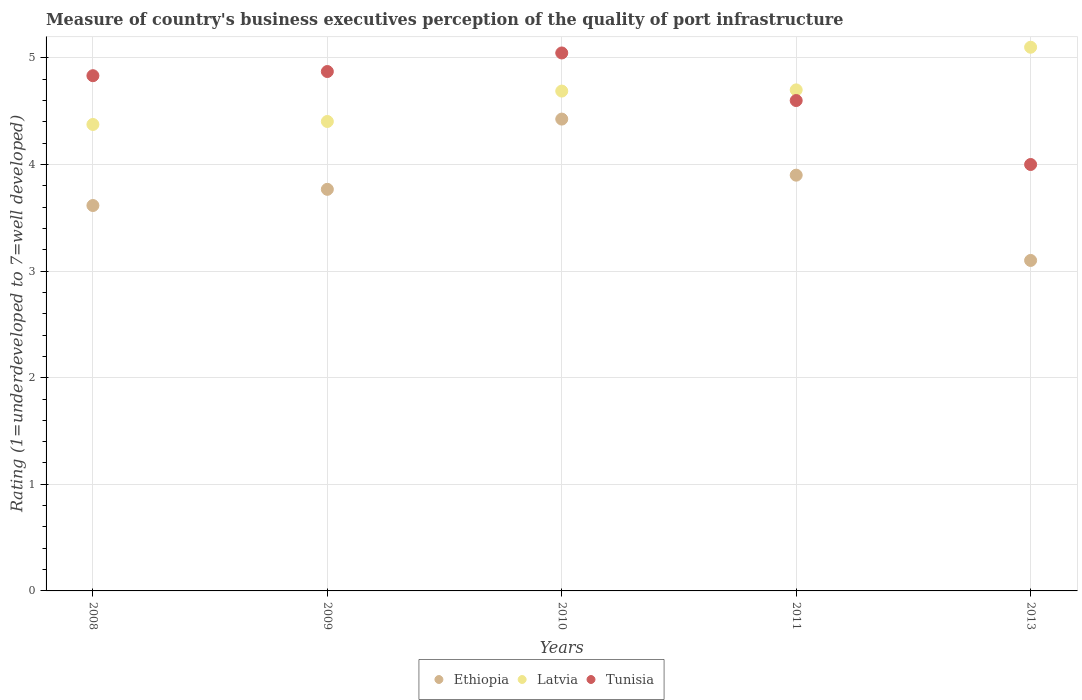How many different coloured dotlines are there?
Offer a terse response. 3. Is the number of dotlines equal to the number of legend labels?
Offer a terse response. Yes. What is the ratings of the quality of port infrastructure in Latvia in 2008?
Provide a short and direct response. 4.38. Across all years, what is the maximum ratings of the quality of port infrastructure in Ethiopia?
Ensure brevity in your answer.  4.43. Across all years, what is the minimum ratings of the quality of port infrastructure in Ethiopia?
Offer a terse response. 3.1. What is the total ratings of the quality of port infrastructure in Latvia in the graph?
Your answer should be compact. 23.27. What is the difference between the ratings of the quality of port infrastructure in Ethiopia in 2010 and that in 2011?
Provide a short and direct response. 0.53. What is the difference between the ratings of the quality of port infrastructure in Latvia in 2011 and the ratings of the quality of port infrastructure in Tunisia in 2013?
Offer a very short reply. 0.7. What is the average ratings of the quality of port infrastructure in Tunisia per year?
Offer a very short reply. 4.67. In the year 2013, what is the difference between the ratings of the quality of port infrastructure in Tunisia and ratings of the quality of port infrastructure in Ethiopia?
Give a very brief answer. 0.9. What is the ratio of the ratings of the quality of port infrastructure in Ethiopia in 2009 to that in 2013?
Provide a succinct answer. 1.22. Is the ratings of the quality of port infrastructure in Ethiopia in 2009 less than that in 2011?
Ensure brevity in your answer.  Yes. What is the difference between the highest and the second highest ratings of the quality of port infrastructure in Tunisia?
Give a very brief answer. 0.17. What is the difference between the highest and the lowest ratings of the quality of port infrastructure in Tunisia?
Keep it short and to the point. 1.05. In how many years, is the ratings of the quality of port infrastructure in Tunisia greater than the average ratings of the quality of port infrastructure in Tunisia taken over all years?
Give a very brief answer. 3. Is it the case that in every year, the sum of the ratings of the quality of port infrastructure in Tunisia and ratings of the quality of port infrastructure in Latvia  is greater than the ratings of the quality of port infrastructure in Ethiopia?
Offer a terse response. Yes. Does the ratings of the quality of port infrastructure in Latvia monotonically increase over the years?
Provide a succinct answer. Yes. How many dotlines are there?
Make the answer very short. 3. How many years are there in the graph?
Offer a terse response. 5. What is the difference between two consecutive major ticks on the Y-axis?
Give a very brief answer. 1. Are the values on the major ticks of Y-axis written in scientific E-notation?
Provide a short and direct response. No. Does the graph contain grids?
Your answer should be compact. Yes. Where does the legend appear in the graph?
Offer a very short reply. Bottom center. How many legend labels are there?
Your answer should be very brief. 3. What is the title of the graph?
Ensure brevity in your answer.  Measure of country's business executives perception of the quality of port infrastructure. What is the label or title of the Y-axis?
Offer a very short reply. Rating (1=underdeveloped to 7=well developed). What is the Rating (1=underdeveloped to 7=well developed) of Ethiopia in 2008?
Keep it short and to the point. 3.62. What is the Rating (1=underdeveloped to 7=well developed) of Latvia in 2008?
Keep it short and to the point. 4.38. What is the Rating (1=underdeveloped to 7=well developed) of Tunisia in 2008?
Your response must be concise. 4.83. What is the Rating (1=underdeveloped to 7=well developed) of Ethiopia in 2009?
Offer a terse response. 3.77. What is the Rating (1=underdeveloped to 7=well developed) of Latvia in 2009?
Ensure brevity in your answer.  4.4. What is the Rating (1=underdeveloped to 7=well developed) of Tunisia in 2009?
Your answer should be compact. 4.87. What is the Rating (1=underdeveloped to 7=well developed) in Ethiopia in 2010?
Offer a very short reply. 4.43. What is the Rating (1=underdeveloped to 7=well developed) in Latvia in 2010?
Offer a very short reply. 4.69. What is the Rating (1=underdeveloped to 7=well developed) of Tunisia in 2010?
Provide a short and direct response. 5.05. What is the Rating (1=underdeveloped to 7=well developed) in Tunisia in 2011?
Keep it short and to the point. 4.6. What is the Rating (1=underdeveloped to 7=well developed) in Ethiopia in 2013?
Your response must be concise. 3.1. What is the Rating (1=underdeveloped to 7=well developed) of Tunisia in 2013?
Your answer should be compact. 4. Across all years, what is the maximum Rating (1=underdeveloped to 7=well developed) in Ethiopia?
Your answer should be very brief. 4.43. Across all years, what is the maximum Rating (1=underdeveloped to 7=well developed) in Tunisia?
Your response must be concise. 5.05. Across all years, what is the minimum Rating (1=underdeveloped to 7=well developed) in Latvia?
Give a very brief answer. 4.38. Across all years, what is the minimum Rating (1=underdeveloped to 7=well developed) in Tunisia?
Offer a very short reply. 4. What is the total Rating (1=underdeveloped to 7=well developed) in Ethiopia in the graph?
Make the answer very short. 18.81. What is the total Rating (1=underdeveloped to 7=well developed) of Latvia in the graph?
Provide a short and direct response. 23.27. What is the total Rating (1=underdeveloped to 7=well developed) in Tunisia in the graph?
Offer a very short reply. 23.35. What is the difference between the Rating (1=underdeveloped to 7=well developed) of Ethiopia in 2008 and that in 2009?
Keep it short and to the point. -0.15. What is the difference between the Rating (1=underdeveloped to 7=well developed) of Latvia in 2008 and that in 2009?
Give a very brief answer. -0.03. What is the difference between the Rating (1=underdeveloped to 7=well developed) of Tunisia in 2008 and that in 2009?
Provide a short and direct response. -0.04. What is the difference between the Rating (1=underdeveloped to 7=well developed) of Ethiopia in 2008 and that in 2010?
Offer a very short reply. -0.81. What is the difference between the Rating (1=underdeveloped to 7=well developed) of Latvia in 2008 and that in 2010?
Offer a very short reply. -0.31. What is the difference between the Rating (1=underdeveloped to 7=well developed) in Tunisia in 2008 and that in 2010?
Your answer should be very brief. -0.21. What is the difference between the Rating (1=underdeveloped to 7=well developed) of Ethiopia in 2008 and that in 2011?
Provide a short and direct response. -0.28. What is the difference between the Rating (1=underdeveloped to 7=well developed) in Latvia in 2008 and that in 2011?
Ensure brevity in your answer.  -0.32. What is the difference between the Rating (1=underdeveloped to 7=well developed) of Tunisia in 2008 and that in 2011?
Keep it short and to the point. 0.23. What is the difference between the Rating (1=underdeveloped to 7=well developed) of Ethiopia in 2008 and that in 2013?
Give a very brief answer. 0.52. What is the difference between the Rating (1=underdeveloped to 7=well developed) of Latvia in 2008 and that in 2013?
Provide a short and direct response. -0.72. What is the difference between the Rating (1=underdeveloped to 7=well developed) of Tunisia in 2008 and that in 2013?
Offer a very short reply. 0.83. What is the difference between the Rating (1=underdeveloped to 7=well developed) of Ethiopia in 2009 and that in 2010?
Your answer should be very brief. -0.66. What is the difference between the Rating (1=underdeveloped to 7=well developed) of Latvia in 2009 and that in 2010?
Ensure brevity in your answer.  -0.29. What is the difference between the Rating (1=underdeveloped to 7=well developed) of Tunisia in 2009 and that in 2010?
Offer a terse response. -0.17. What is the difference between the Rating (1=underdeveloped to 7=well developed) in Ethiopia in 2009 and that in 2011?
Your response must be concise. -0.13. What is the difference between the Rating (1=underdeveloped to 7=well developed) of Latvia in 2009 and that in 2011?
Offer a very short reply. -0.3. What is the difference between the Rating (1=underdeveloped to 7=well developed) in Tunisia in 2009 and that in 2011?
Your response must be concise. 0.27. What is the difference between the Rating (1=underdeveloped to 7=well developed) in Ethiopia in 2009 and that in 2013?
Offer a terse response. 0.67. What is the difference between the Rating (1=underdeveloped to 7=well developed) in Latvia in 2009 and that in 2013?
Provide a short and direct response. -0.7. What is the difference between the Rating (1=underdeveloped to 7=well developed) in Tunisia in 2009 and that in 2013?
Ensure brevity in your answer.  0.87. What is the difference between the Rating (1=underdeveloped to 7=well developed) in Ethiopia in 2010 and that in 2011?
Offer a very short reply. 0.53. What is the difference between the Rating (1=underdeveloped to 7=well developed) of Latvia in 2010 and that in 2011?
Your answer should be very brief. -0.01. What is the difference between the Rating (1=underdeveloped to 7=well developed) of Tunisia in 2010 and that in 2011?
Offer a terse response. 0.45. What is the difference between the Rating (1=underdeveloped to 7=well developed) in Ethiopia in 2010 and that in 2013?
Make the answer very short. 1.33. What is the difference between the Rating (1=underdeveloped to 7=well developed) of Latvia in 2010 and that in 2013?
Provide a succinct answer. -0.41. What is the difference between the Rating (1=underdeveloped to 7=well developed) of Tunisia in 2010 and that in 2013?
Your response must be concise. 1.05. What is the difference between the Rating (1=underdeveloped to 7=well developed) of Ethiopia in 2011 and that in 2013?
Your answer should be very brief. 0.8. What is the difference between the Rating (1=underdeveloped to 7=well developed) in Ethiopia in 2008 and the Rating (1=underdeveloped to 7=well developed) in Latvia in 2009?
Provide a short and direct response. -0.79. What is the difference between the Rating (1=underdeveloped to 7=well developed) in Ethiopia in 2008 and the Rating (1=underdeveloped to 7=well developed) in Tunisia in 2009?
Offer a very short reply. -1.26. What is the difference between the Rating (1=underdeveloped to 7=well developed) of Latvia in 2008 and the Rating (1=underdeveloped to 7=well developed) of Tunisia in 2009?
Ensure brevity in your answer.  -0.5. What is the difference between the Rating (1=underdeveloped to 7=well developed) of Ethiopia in 2008 and the Rating (1=underdeveloped to 7=well developed) of Latvia in 2010?
Your answer should be very brief. -1.07. What is the difference between the Rating (1=underdeveloped to 7=well developed) in Ethiopia in 2008 and the Rating (1=underdeveloped to 7=well developed) in Tunisia in 2010?
Offer a very short reply. -1.43. What is the difference between the Rating (1=underdeveloped to 7=well developed) in Latvia in 2008 and the Rating (1=underdeveloped to 7=well developed) in Tunisia in 2010?
Make the answer very short. -0.67. What is the difference between the Rating (1=underdeveloped to 7=well developed) of Ethiopia in 2008 and the Rating (1=underdeveloped to 7=well developed) of Latvia in 2011?
Your answer should be very brief. -1.08. What is the difference between the Rating (1=underdeveloped to 7=well developed) in Ethiopia in 2008 and the Rating (1=underdeveloped to 7=well developed) in Tunisia in 2011?
Your answer should be very brief. -0.98. What is the difference between the Rating (1=underdeveloped to 7=well developed) of Latvia in 2008 and the Rating (1=underdeveloped to 7=well developed) of Tunisia in 2011?
Provide a short and direct response. -0.22. What is the difference between the Rating (1=underdeveloped to 7=well developed) of Ethiopia in 2008 and the Rating (1=underdeveloped to 7=well developed) of Latvia in 2013?
Provide a short and direct response. -1.48. What is the difference between the Rating (1=underdeveloped to 7=well developed) of Ethiopia in 2008 and the Rating (1=underdeveloped to 7=well developed) of Tunisia in 2013?
Your answer should be compact. -0.38. What is the difference between the Rating (1=underdeveloped to 7=well developed) in Latvia in 2008 and the Rating (1=underdeveloped to 7=well developed) in Tunisia in 2013?
Your answer should be very brief. 0.38. What is the difference between the Rating (1=underdeveloped to 7=well developed) of Ethiopia in 2009 and the Rating (1=underdeveloped to 7=well developed) of Latvia in 2010?
Offer a terse response. -0.92. What is the difference between the Rating (1=underdeveloped to 7=well developed) in Ethiopia in 2009 and the Rating (1=underdeveloped to 7=well developed) in Tunisia in 2010?
Your answer should be very brief. -1.28. What is the difference between the Rating (1=underdeveloped to 7=well developed) of Latvia in 2009 and the Rating (1=underdeveloped to 7=well developed) of Tunisia in 2010?
Your answer should be very brief. -0.64. What is the difference between the Rating (1=underdeveloped to 7=well developed) in Ethiopia in 2009 and the Rating (1=underdeveloped to 7=well developed) in Latvia in 2011?
Your answer should be compact. -0.93. What is the difference between the Rating (1=underdeveloped to 7=well developed) in Ethiopia in 2009 and the Rating (1=underdeveloped to 7=well developed) in Tunisia in 2011?
Offer a terse response. -0.83. What is the difference between the Rating (1=underdeveloped to 7=well developed) in Latvia in 2009 and the Rating (1=underdeveloped to 7=well developed) in Tunisia in 2011?
Make the answer very short. -0.2. What is the difference between the Rating (1=underdeveloped to 7=well developed) in Ethiopia in 2009 and the Rating (1=underdeveloped to 7=well developed) in Latvia in 2013?
Ensure brevity in your answer.  -1.33. What is the difference between the Rating (1=underdeveloped to 7=well developed) in Ethiopia in 2009 and the Rating (1=underdeveloped to 7=well developed) in Tunisia in 2013?
Your answer should be very brief. -0.23. What is the difference between the Rating (1=underdeveloped to 7=well developed) in Latvia in 2009 and the Rating (1=underdeveloped to 7=well developed) in Tunisia in 2013?
Make the answer very short. 0.4. What is the difference between the Rating (1=underdeveloped to 7=well developed) in Ethiopia in 2010 and the Rating (1=underdeveloped to 7=well developed) in Latvia in 2011?
Your answer should be compact. -0.27. What is the difference between the Rating (1=underdeveloped to 7=well developed) in Ethiopia in 2010 and the Rating (1=underdeveloped to 7=well developed) in Tunisia in 2011?
Keep it short and to the point. -0.17. What is the difference between the Rating (1=underdeveloped to 7=well developed) of Latvia in 2010 and the Rating (1=underdeveloped to 7=well developed) of Tunisia in 2011?
Offer a very short reply. 0.09. What is the difference between the Rating (1=underdeveloped to 7=well developed) in Ethiopia in 2010 and the Rating (1=underdeveloped to 7=well developed) in Latvia in 2013?
Offer a terse response. -0.67. What is the difference between the Rating (1=underdeveloped to 7=well developed) in Ethiopia in 2010 and the Rating (1=underdeveloped to 7=well developed) in Tunisia in 2013?
Your answer should be very brief. 0.43. What is the difference between the Rating (1=underdeveloped to 7=well developed) in Latvia in 2010 and the Rating (1=underdeveloped to 7=well developed) in Tunisia in 2013?
Keep it short and to the point. 0.69. What is the difference between the Rating (1=underdeveloped to 7=well developed) of Ethiopia in 2011 and the Rating (1=underdeveloped to 7=well developed) of Tunisia in 2013?
Provide a short and direct response. -0.1. What is the difference between the Rating (1=underdeveloped to 7=well developed) of Latvia in 2011 and the Rating (1=underdeveloped to 7=well developed) of Tunisia in 2013?
Give a very brief answer. 0.7. What is the average Rating (1=underdeveloped to 7=well developed) in Ethiopia per year?
Offer a very short reply. 3.76. What is the average Rating (1=underdeveloped to 7=well developed) of Latvia per year?
Give a very brief answer. 4.65. What is the average Rating (1=underdeveloped to 7=well developed) in Tunisia per year?
Make the answer very short. 4.67. In the year 2008, what is the difference between the Rating (1=underdeveloped to 7=well developed) in Ethiopia and Rating (1=underdeveloped to 7=well developed) in Latvia?
Your answer should be very brief. -0.76. In the year 2008, what is the difference between the Rating (1=underdeveloped to 7=well developed) of Ethiopia and Rating (1=underdeveloped to 7=well developed) of Tunisia?
Provide a succinct answer. -1.22. In the year 2008, what is the difference between the Rating (1=underdeveloped to 7=well developed) in Latvia and Rating (1=underdeveloped to 7=well developed) in Tunisia?
Provide a succinct answer. -0.46. In the year 2009, what is the difference between the Rating (1=underdeveloped to 7=well developed) in Ethiopia and Rating (1=underdeveloped to 7=well developed) in Latvia?
Offer a terse response. -0.64. In the year 2009, what is the difference between the Rating (1=underdeveloped to 7=well developed) in Ethiopia and Rating (1=underdeveloped to 7=well developed) in Tunisia?
Provide a succinct answer. -1.1. In the year 2009, what is the difference between the Rating (1=underdeveloped to 7=well developed) in Latvia and Rating (1=underdeveloped to 7=well developed) in Tunisia?
Ensure brevity in your answer.  -0.47. In the year 2010, what is the difference between the Rating (1=underdeveloped to 7=well developed) of Ethiopia and Rating (1=underdeveloped to 7=well developed) of Latvia?
Give a very brief answer. -0.26. In the year 2010, what is the difference between the Rating (1=underdeveloped to 7=well developed) in Ethiopia and Rating (1=underdeveloped to 7=well developed) in Tunisia?
Offer a very short reply. -0.62. In the year 2010, what is the difference between the Rating (1=underdeveloped to 7=well developed) of Latvia and Rating (1=underdeveloped to 7=well developed) of Tunisia?
Your response must be concise. -0.36. In the year 2011, what is the difference between the Rating (1=underdeveloped to 7=well developed) in Ethiopia and Rating (1=underdeveloped to 7=well developed) in Latvia?
Offer a very short reply. -0.8. In the year 2011, what is the difference between the Rating (1=underdeveloped to 7=well developed) in Latvia and Rating (1=underdeveloped to 7=well developed) in Tunisia?
Offer a terse response. 0.1. In the year 2013, what is the difference between the Rating (1=underdeveloped to 7=well developed) in Ethiopia and Rating (1=underdeveloped to 7=well developed) in Latvia?
Provide a short and direct response. -2. What is the ratio of the Rating (1=underdeveloped to 7=well developed) in Ethiopia in 2008 to that in 2009?
Provide a succinct answer. 0.96. What is the ratio of the Rating (1=underdeveloped to 7=well developed) in Latvia in 2008 to that in 2009?
Ensure brevity in your answer.  0.99. What is the ratio of the Rating (1=underdeveloped to 7=well developed) of Tunisia in 2008 to that in 2009?
Offer a very short reply. 0.99. What is the ratio of the Rating (1=underdeveloped to 7=well developed) of Ethiopia in 2008 to that in 2010?
Give a very brief answer. 0.82. What is the ratio of the Rating (1=underdeveloped to 7=well developed) in Latvia in 2008 to that in 2010?
Your response must be concise. 0.93. What is the ratio of the Rating (1=underdeveloped to 7=well developed) in Tunisia in 2008 to that in 2010?
Make the answer very short. 0.96. What is the ratio of the Rating (1=underdeveloped to 7=well developed) in Ethiopia in 2008 to that in 2011?
Keep it short and to the point. 0.93. What is the ratio of the Rating (1=underdeveloped to 7=well developed) in Latvia in 2008 to that in 2011?
Provide a succinct answer. 0.93. What is the ratio of the Rating (1=underdeveloped to 7=well developed) of Tunisia in 2008 to that in 2011?
Keep it short and to the point. 1.05. What is the ratio of the Rating (1=underdeveloped to 7=well developed) in Ethiopia in 2008 to that in 2013?
Make the answer very short. 1.17. What is the ratio of the Rating (1=underdeveloped to 7=well developed) of Latvia in 2008 to that in 2013?
Offer a terse response. 0.86. What is the ratio of the Rating (1=underdeveloped to 7=well developed) of Tunisia in 2008 to that in 2013?
Give a very brief answer. 1.21. What is the ratio of the Rating (1=underdeveloped to 7=well developed) of Ethiopia in 2009 to that in 2010?
Offer a very short reply. 0.85. What is the ratio of the Rating (1=underdeveloped to 7=well developed) in Latvia in 2009 to that in 2010?
Give a very brief answer. 0.94. What is the ratio of the Rating (1=underdeveloped to 7=well developed) of Tunisia in 2009 to that in 2010?
Provide a short and direct response. 0.97. What is the ratio of the Rating (1=underdeveloped to 7=well developed) in Ethiopia in 2009 to that in 2011?
Provide a short and direct response. 0.97. What is the ratio of the Rating (1=underdeveloped to 7=well developed) in Latvia in 2009 to that in 2011?
Your answer should be compact. 0.94. What is the ratio of the Rating (1=underdeveloped to 7=well developed) in Tunisia in 2009 to that in 2011?
Give a very brief answer. 1.06. What is the ratio of the Rating (1=underdeveloped to 7=well developed) of Ethiopia in 2009 to that in 2013?
Keep it short and to the point. 1.22. What is the ratio of the Rating (1=underdeveloped to 7=well developed) of Latvia in 2009 to that in 2013?
Provide a short and direct response. 0.86. What is the ratio of the Rating (1=underdeveloped to 7=well developed) in Tunisia in 2009 to that in 2013?
Give a very brief answer. 1.22. What is the ratio of the Rating (1=underdeveloped to 7=well developed) in Ethiopia in 2010 to that in 2011?
Offer a terse response. 1.13. What is the ratio of the Rating (1=underdeveloped to 7=well developed) in Tunisia in 2010 to that in 2011?
Ensure brevity in your answer.  1.1. What is the ratio of the Rating (1=underdeveloped to 7=well developed) of Ethiopia in 2010 to that in 2013?
Your response must be concise. 1.43. What is the ratio of the Rating (1=underdeveloped to 7=well developed) of Latvia in 2010 to that in 2013?
Your answer should be very brief. 0.92. What is the ratio of the Rating (1=underdeveloped to 7=well developed) in Tunisia in 2010 to that in 2013?
Keep it short and to the point. 1.26. What is the ratio of the Rating (1=underdeveloped to 7=well developed) in Ethiopia in 2011 to that in 2013?
Provide a succinct answer. 1.26. What is the ratio of the Rating (1=underdeveloped to 7=well developed) of Latvia in 2011 to that in 2013?
Your answer should be compact. 0.92. What is the ratio of the Rating (1=underdeveloped to 7=well developed) in Tunisia in 2011 to that in 2013?
Your answer should be very brief. 1.15. What is the difference between the highest and the second highest Rating (1=underdeveloped to 7=well developed) of Ethiopia?
Give a very brief answer. 0.53. What is the difference between the highest and the second highest Rating (1=underdeveloped to 7=well developed) in Tunisia?
Give a very brief answer. 0.17. What is the difference between the highest and the lowest Rating (1=underdeveloped to 7=well developed) in Ethiopia?
Offer a very short reply. 1.33. What is the difference between the highest and the lowest Rating (1=underdeveloped to 7=well developed) in Latvia?
Ensure brevity in your answer.  0.72. What is the difference between the highest and the lowest Rating (1=underdeveloped to 7=well developed) in Tunisia?
Provide a short and direct response. 1.05. 